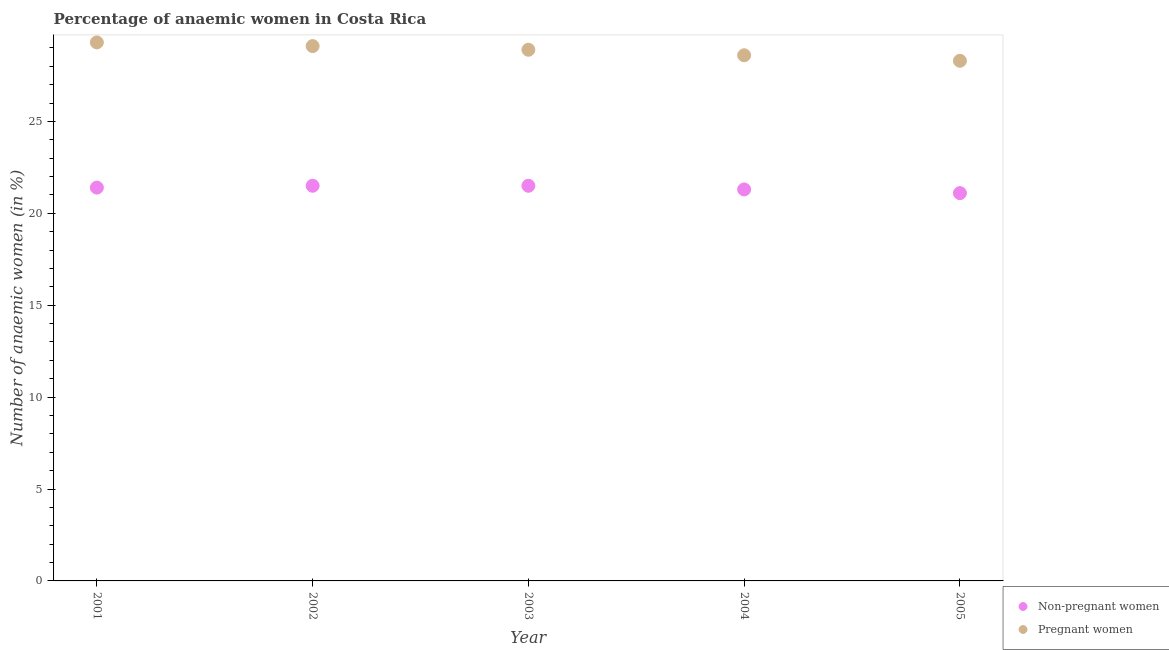How many different coloured dotlines are there?
Provide a short and direct response. 2. What is the percentage of pregnant anaemic women in 2003?
Offer a very short reply. 28.9. Across all years, what is the maximum percentage of pregnant anaemic women?
Offer a very short reply. 29.3. Across all years, what is the minimum percentage of pregnant anaemic women?
Make the answer very short. 28.3. In which year was the percentage of pregnant anaemic women maximum?
Your answer should be compact. 2001. In which year was the percentage of non-pregnant anaemic women minimum?
Offer a terse response. 2005. What is the total percentage of pregnant anaemic women in the graph?
Provide a short and direct response. 144.2. What is the difference between the percentage of non-pregnant anaemic women in 2001 and that in 2003?
Offer a very short reply. -0.1. What is the difference between the percentage of non-pregnant anaemic women in 2001 and the percentage of pregnant anaemic women in 2005?
Your answer should be compact. -6.9. What is the average percentage of non-pregnant anaemic women per year?
Give a very brief answer. 21.36. In the year 2002, what is the difference between the percentage of pregnant anaemic women and percentage of non-pregnant anaemic women?
Offer a terse response. 7.6. What is the ratio of the percentage of non-pregnant anaemic women in 2001 to that in 2002?
Your answer should be compact. 1. Is the percentage of pregnant anaemic women in 2001 less than that in 2005?
Your answer should be compact. No. In how many years, is the percentage of non-pregnant anaemic women greater than the average percentage of non-pregnant anaemic women taken over all years?
Your answer should be compact. 3. Is the sum of the percentage of pregnant anaemic women in 2001 and 2003 greater than the maximum percentage of non-pregnant anaemic women across all years?
Offer a very short reply. Yes. Does the percentage of pregnant anaemic women monotonically increase over the years?
Make the answer very short. No. Is the percentage of pregnant anaemic women strictly greater than the percentage of non-pregnant anaemic women over the years?
Provide a succinct answer. Yes. Is the percentage of non-pregnant anaemic women strictly less than the percentage of pregnant anaemic women over the years?
Keep it short and to the point. Yes. How many years are there in the graph?
Your answer should be very brief. 5. What is the difference between two consecutive major ticks on the Y-axis?
Your answer should be very brief. 5. Are the values on the major ticks of Y-axis written in scientific E-notation?
Your answer should be compact. No. Does the graph contain any zero values?
Give a very brief answer. No. Where does the legend appear in the graph?
Provide a short and direct response. Bottom right. How many legend labels are there?
Your response must be concise. 2. How are the legend labels stacked?
Make the answer very short. Vertical. What is the title of the graph?
Give a very brief answer. Percentage of anaemic women in Costa Rica. What is the label or title of the X-axis?
Ensure brevity in your answer.  Year. What is the label or title of the Y-axis?
Offer a very short reply. Number of anaemic women (in %). What is the Number of anaemic women (in %) in Non-pregnant women in 2001?
Ensure brevity in your answer.  21.4. What is the Number of anaemic women (in %) of Pregnant women in 2001?
Offer a very short reply. 29.3. What is the Number of anaemic women (in %) of Non-pregnant women in 2002?
Your response must be concise. 21.5. What is the Number of anaemic women (in %) of Pregnant women in 2002?
Keep it short and to the point. 29.1. What is the Number of anaemic women (in %) in Pregnant women in 2003?
Your answer should be very brief. 28.9. What is the Number of anaemic women (in %) in Non-pregnant women in 2004?
Provide a short and direct response. 21.3. What is the Number of anaemic women (in %) in Pregnant women in 2004?
Give a very brief answer. 28.6. What is the Number of anaemic women (in %) of Non-pregnant women in 2005?
Your answer should be very brief. 21.1. What is the Number of anaemic women (in %) in Pregnant women in 2005?
Keep it short and to the point. 28.3. Across all years, what is the maximum Number of anaemic women (in %) in Pregnant women?
Your answer should be very brief. 29.3. Across all years, what is the minimum Number of anaemic women (in %) of Non-pregnant women?
Your response must be concise. 21.1. Across all years, what is the minimum Number of anaemic women (in %) in Pregnant women?
Your answer should be very brief. 28.3. What is the total Number of anaemic women (in %) in Non-pregnant women in the graph?
Offer a very short reply. 106.8. What is the total Number of anaemic women (in %) of Pregnant women in the graph?
Provide a succinct answer. 144.2. What is the difference between the Number of anaemic women (in %) in Pregnant women in 2001 and that in 2002?
Provide a short and direct response. 0.2. What is the difference between the Number of anaemic women (in %) of Pregnant women in 2001 and that in 2003?
Provide a short and direct response. 0.4. What is the difference between the Number of anaemic women (in %) of Non-pregnant women in 2001 and that in 2004?
Keep it short and to the point. 0.1. What is the difference between the Number of anaemic women (in %) of Non-pregnant women in 2001 and that in 2005?
Offer a terse response. 0.3. What is the difference between the Number of anaemic women (in %) in Pregnant women in 2001 and that in 2005?
Give a very brief answer. 1. What is the difference between the Number of anaemic women (in %) of Non-pregnant women in 2002 and that in 2003?
Your answer should be compact. 0. What is the difference between the Number of anaemic women (in %) in Pregnant women in 2002 and that in 2004?
Keep it short and to the point. 0.5. What is the difference between the Number of anaemic women (in %) of Pregnant women in 2003 and that in 2005?
Ensure brevity in your answer.  0.6. What is the difference between the Number of anaemic women (in %) in Pregnant women in 2004 and that in 2005?
Keep it short and to the point. 0.3. What is the difference between the Number of anaemic women (in %) of Non-pregnant women in 2001 and the Number of anaemic women (in %) of Pregnant women in 2004?
Give a very brief answer. -7.2. What is the difference between the Number of anaemic women (in %) in Non-pregnant women in 2002 and the Number of anaemic women (in %) in Pregnant women in 2003?
Keep it short and to the point. -7.4. What is the difference between the Number of anaemic women (in %) of Non-pregnant women in 2002 and the Number of anaemic women (in %) of Pregnant women in 2005?
Give a very brief answer. -6.8. What is the average Number of anaemic women (in %) of Non-pregnant women per year?
Make the answer very short. 21.36. What is the average Number of anaemic women (in %) of Pregnant women per year?
Your answer should be very brief. 28.84. In the year 2003, what is the difference between the Number of anaemic women (in %) of Non-pregnant women and Number of anaemic women (in %) of Pregnant women?
Offer a terse response. -7.4. In the year 2004, what is the difference between the Number of anaemic women (in %) of Non-pregnant women and Number of anaemic women (in %) of Pregnant women?
Offer a terse response. -7.3. What is the ratio of the Number of anaemic women (in %) of Pregnant women in 2001 to that in 2003?
Provide a short and direct response. 1.01. What is the ratio of the Number of anaemic women (in %) in Non-pregnant women in 2001 to that in 2004?
Provide a short and direct response. 1. What is the ratio of the Number of anaemic women (in %) in Pregnant women in 2001 to that in 2004?
Make the answer very short. 1.02. What is the ratio of the Number of anaemic women (in %) in Non-pregnant women in 2001 to that in 2005?
Give a very brief answer. 1.01. What is the ratio of the Number of anaemic women (in %) of Pregnant women in 2001 to that in 2005?
Your response must be concise. 1.04. What is the ratio of the Number of anaemic women (in %) of Non-pregnant women in 2002 to that in 2003?
Provide a short and direct response. 1. What is the ratio of the Number of anaemic women (in %) of Pregnant women in 2002 to that in 2003?
Your answer should be compact. 1.01. What is the ratio of the Number of anaemic women (in %) of Non-pregnant women in 2002 to that in 2004?
Offer a terse response. 1.01. What is the ratio of the Number of anaemic women (in %) of Pregnant women in 2002 to that in 2004?
Make the answer very short. 1.02. What is the ratio of the Number of anaemic women (in %) in Pregnant women in 2002 to that in 2005?
Provide a succinct answer. 1.03. What is the ratio of the Number of anaemic women (in %) in Non-pregnant women in 2003 to that in 2004?
Your answer should be compact. 1.01. What is the ratio of the Number of anaemic women (in %) in Pregnant women in 2003 to that in 2004?
Give a very brief answer. 1.01. What is the ratio of the Number of anaemic women (in %) of Non-pregnant women in 2003 to that in 2005?
Offer a very short reply. 1.02. What is the ratio of the Number of anaemic women (in %) of Pregnant women in 2003 to that in 2005?
Your response must be concise. 1.02. What is the ratio of the Number of anaemic women (in %) of Non-pregnant women in 2004 to that in 2005?
Offer a very short reply. 1.01. What is the ratio of the Number of anaemic women (in %) of Pregnant women in 2004 to that in 2005?
Keep it short and to the point. 1.01. 